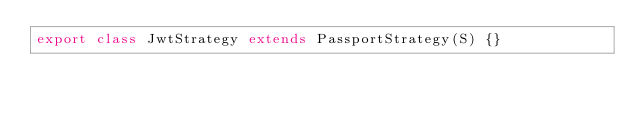<code> <loc_0><loc_0><loc_500><loc_500><_TypeScript_>export class JwtStrategy extends PassportStrategy(S) {}
</code> 